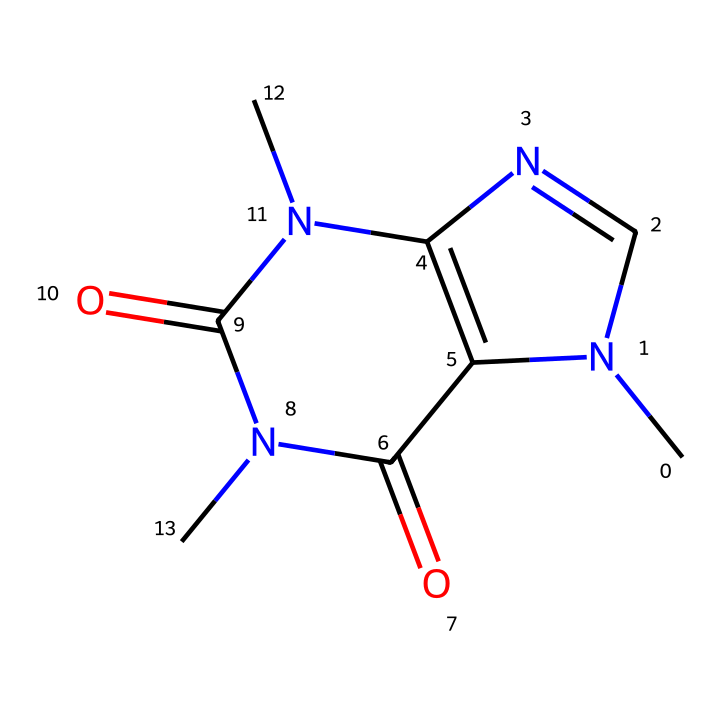What is the molecular formula of caffeine? To find the molecular formula, count the number of each type of atom in the SMILES. From the structure, there are 8 carbon (C), 10 hydrogen (H), and 4 nitrogen (N) atoms, along with 2 oxygen (O) atoms. Thus, the molecular formula is C8H10N4O2.
Answer: C8H10N4O2 How many rings are present in the caffeine structure? In the SMILES representation, the presence of 'N1' and 'N2' indicates where rings start and end. Tracing these points, there are two rings in the structure.
Answer: 2 What functional groups are present in caffeine? Examining the structure, caffeine contains amide (due to the carbonyl groups adjacent to nitrogen atoms) and aromatic groups. Identifying these components can determine the functional groups.
Answer: amide, aromatic What type of compound is caffeine classified as? Caffeine is known to be a stimulant and is classified specifically as an alkaloid, a category of compounds that contain basic nitrogen atoms. The presence of nitrogen in its structure confirms this classification.
Answer: alkaloid What is the significance of nitrogen in the structure of caffeine? Nitrogen atoms in caffeine contribute to its properties as a stimulant, primarily through their role in forming hydrogen bonds and their basic nature, influencing the compound's interaction in biological systems.
Answer: stimulant 